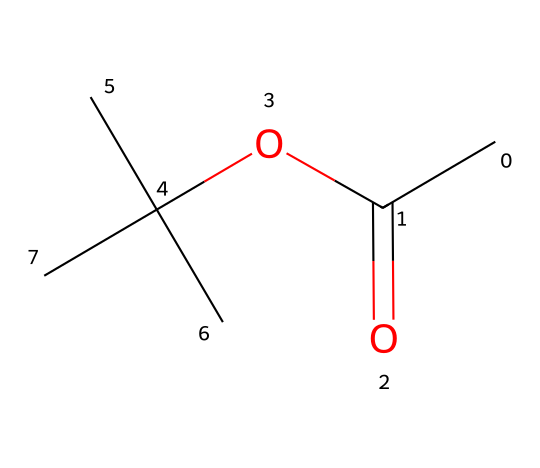How many carbon atoms are present in this chemical? The SMILES representation contains 'CC(=O)OC(C)(C)C' which shows that there are five 'C' letters, indicating five carbon atoms in total.
Answer: 5 What type of functional group is present in this chemical? The structure contains an ester group, which is identified by the 'OC(=O)' portion. Esters are characterized by a carbonyl (C=O) attached to an oxygen atom.
Answer: ester Is this chemical a liquid at room temperature? Non-electrolytes like esters generally possess low vapor pressure and can be liquid at room temperature. The specific structure, such as the presence of branched carbon chains, suggests it may remain liquid under normal conditions.
Answer: yes What is the molecular formula of this chemical? Analyzing the SMILES produces five carbon atoms, ten hydrogen atoms, and two oxygen atoms, leading to the molecular formula C5H10O2.
Answer: C5H10O2 What can you infer about the solubility of this compound in water? Esters, especially branched ones, typically have lower solubility in water because they cannot form strong hydrogen bonds with water molecules, suggesting limited solubility.
Answer: low Which part of the structure contributes to its non-electrolyte nature? The absence of any ionic bonds or highly polar functional groups in the molecule means it does not dissociate into ions, defining it as a non-electrolyte.
Answer: no ionic bonds 